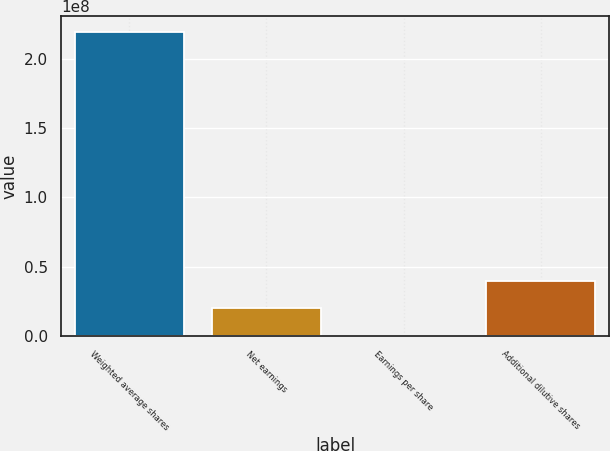Convert chart. <chart><loc_0><loc_0><loc_500><loc_500><bar_chart><fcel>Weighted average shares<fcel>Net earnings<fcel>Earnings per share<fcel>Additional dilutive shares<nl><fcel>2.19403e+08<fcel>1.99457e+07<fcel>0.94<fcel>3.98915e+07<nl></chart> 